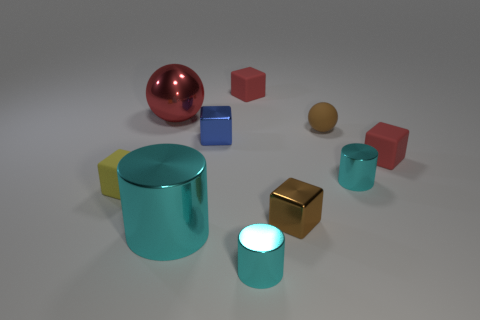Is the shape of the tiny matte object that is behind the rubber ball the same as the cyan metal object on the right side of the tiny brown rubber ball?
Give a very brief answer. No. There is a tiny matte ball; is it the same color as the small metallic cube that is in front of the blue metal block?
Provide a succinct answer. Yes. There is a cylinder that is right of the tiny brown matte sphere; is it the same color as the big metallic cylinder?
Your answer should be very brief. Yes. How many things are either small brown shiny things or cyan shiny cylinders in front of the brown shiny block?
Ensure brevity in your answer.  3. There is a object that is both on the right side of the yellow rubber block and to the left of the large cyan object; what is its material?
Give a very brief answer. Metal. What is the material of the small block that is behind the large red object?
Offer a very short reply. Rubber. What color is the big cylinder that is made of the same material as the large red object?
Give a very brief answer. Cyan. Do the brown metallic thing and the big cyan object on the left side of the blue metallic cube have the same shape?
Offer a very short reply. No. There is a brown metallic cube; are there any small metal objects behind it?
Your answer should be compact. Yes. There is a tiny block that is the same color as the rubber sphere; what material is it?
Offer a terse response. Metal. 